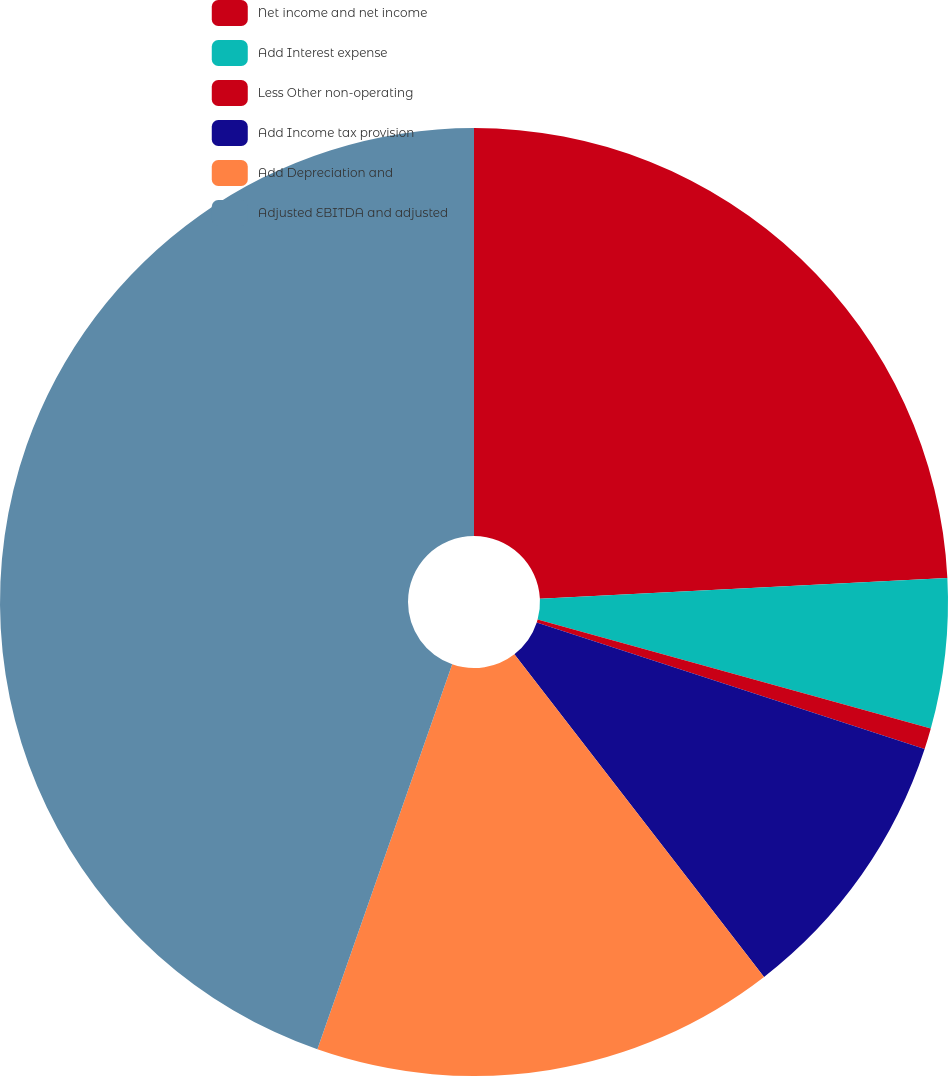Convert chart. <chart><loc_0><loc_0><loc_500><loc_500><pie_chart><fcel>Net income and net income<fcel>Add Interest expense<fcel>Less Other non-operating<fcel>Add Income tax provision<fcel>Add Depreciation and<fcel>Adjusted EBITDA and adjusted<nl><fcel>24.19%<fcel>5.11%<fcel>0.72%<fcel>9.5%<fcel>15.84%<fcel>44.64%<nl></chart> 